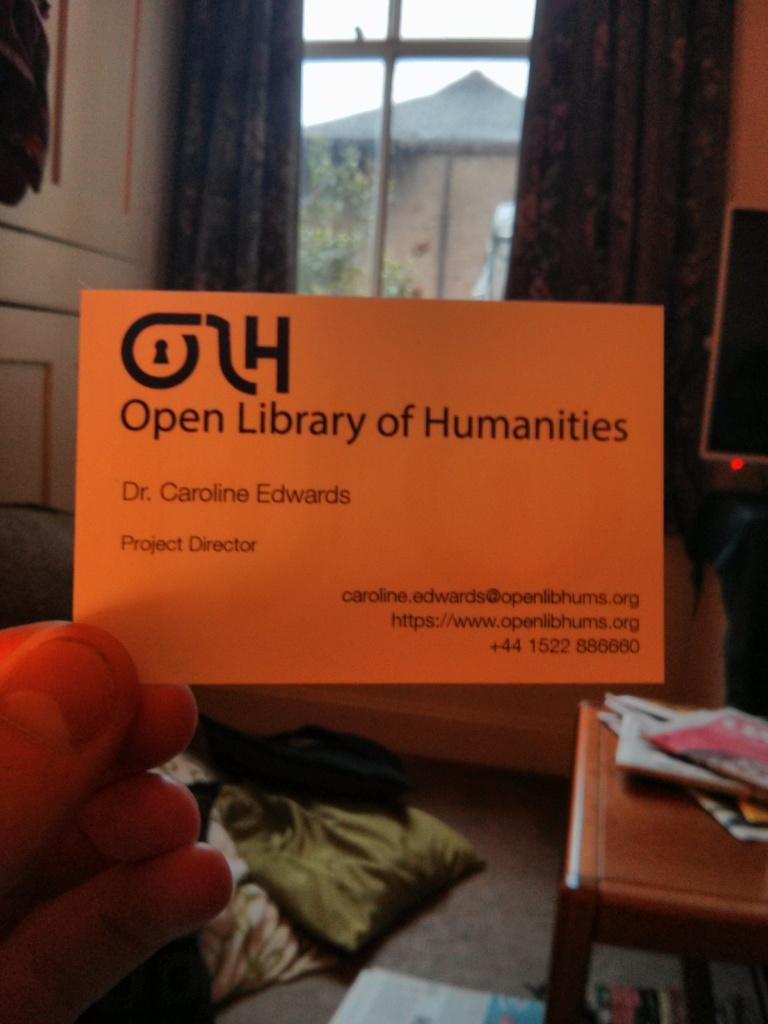<image>
Share a concise interpretation of the image provided. Business card from Dr. Caroline Edwards project director. 